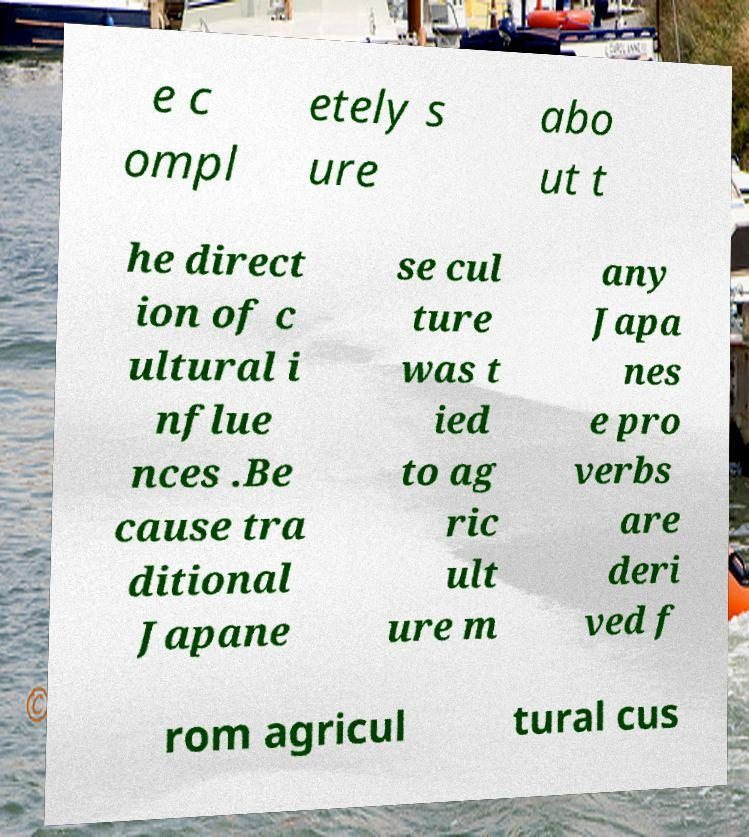What messages or text are displayed in this image? I need them in a readable, typed format. e c ompl etely s ure abo ut t he direct ion of c ultural i nflue nces .Be cause tra ditional Japane se cul ture was t ied to ag ric ult ure m any Japa nes e pro verbs are deri ved f rom agricul tural cus 